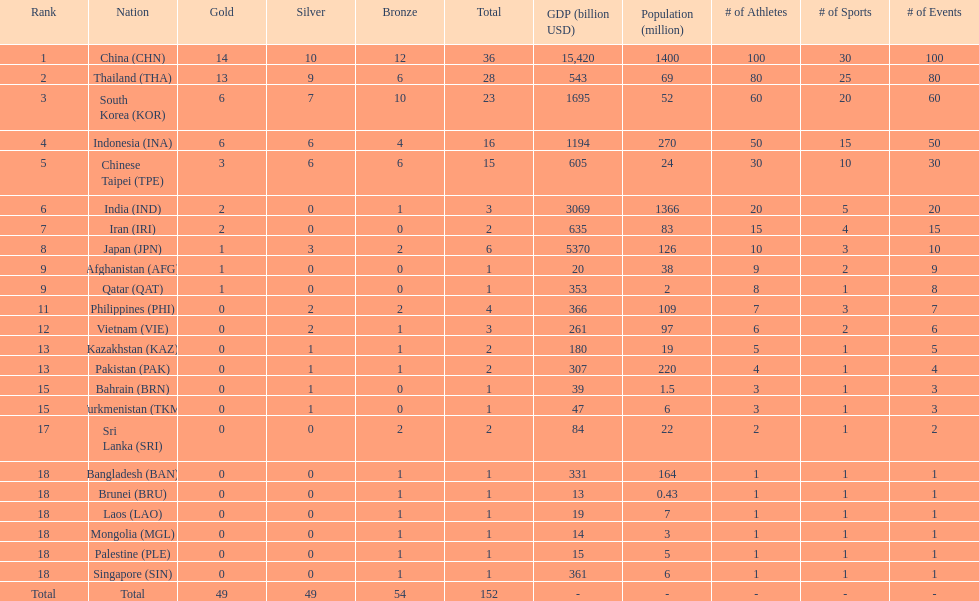How many nations received a medal in each gold, silver, and bronze? 6. 